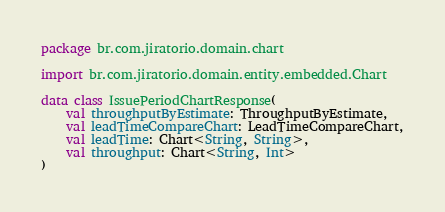Convert code to text. <code><loc_0><loc_0><loc_500><loc_500><_Kotlin_>package br.com.jiratorio.domain.chart

import br.com.jiratorio.domain.entity.embedded.Chart

data class IssuePeriodChartResponse(
    val throughputByEstimate: ThroughputByEstimate,
    val leadTimeCompareChart: LeadTimeCompareChart,
    val leadTime: Chart<String, String>,
    val throughput: Chart<String, Int>
)
</code> 